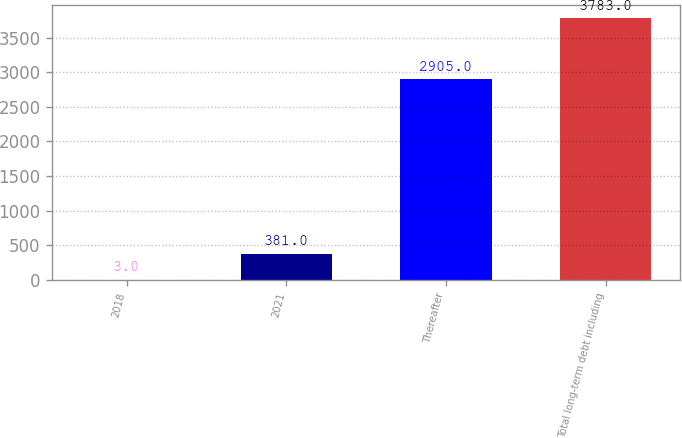Convert chart to OTSL. <chart><loc_0><loc_0><loc_500><loc_500><bar_chart><fcel>2018<fcel>2021<fcel>Thereafter<fcel>Total long-term debt including<nl><fcel>3<fcel>381<fcel>2905<fcel>3783<nl></chart> 